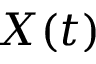<formula> <loc_0><loc_0><loc_500><loc_500>X ( t )</formula> 